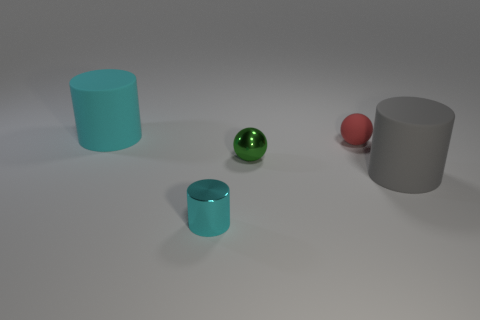What size is the object that is the same color as the metallic cylinder?
Your response must be concise. Large. The object that is made of the same material as the tiny green sphere is what color?
Provide a short and direct response. Cyan. Do the green ball and the tiny thing that is in front of the tiny metal ball have the same material?
Keep it short and to the point. Yes. What color is the metal ball?
Ensure brevity in your answer.  Green. The other cylinder that is made of the same material as the large gray cylinder is what size?
Ensure brevity in your answer.  Large. There is a cyan cylinder that is in front of the big thing that is right of the small cyan shiny object; how many red matte spheres are to the right of it?
Your response must be concise. 1. Does the metallic cylinder have the same color as the big object behind the small matte ball?
Your answer should be very brief. Yes. The matte thing that is the same color as the tiny metallic cylinder is what shape?
Your response must be concise. Cylinder. What material is the cyan cylinder on the right side of the cyan rubber object to the left of the tiny object behind the green shiny object made of?
Give a very brief answer. Metal. There is a small green object that is to the right of the small cyan metal cylinder; is it the same shape as the red object?
Provide a short and direct response. Yes. 